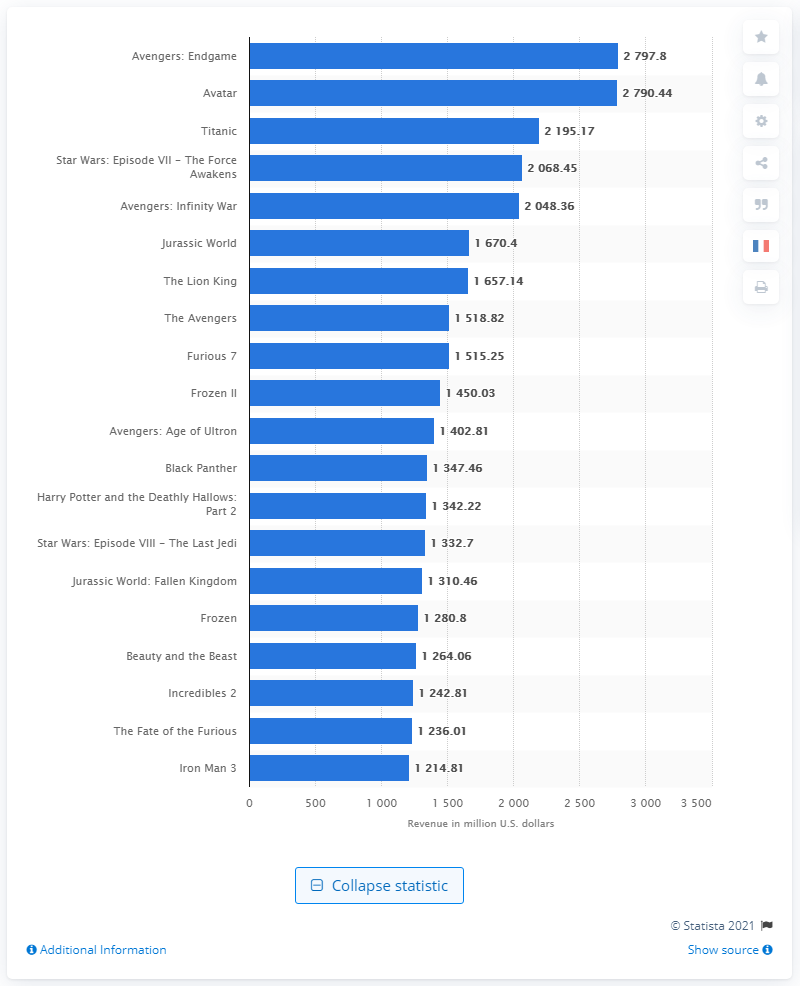Mention a couple of crucial points in this snapshot. As of November 2020, the global box office revenue generated by "Avengers: Endgame" was approximately 2797.8. The gross of "Avatar" was 2797.8 million dollars. As of November 2020, the global box office revenue generated by "Avengers: Endgame" was approximately 2797.8 million US dollars. 